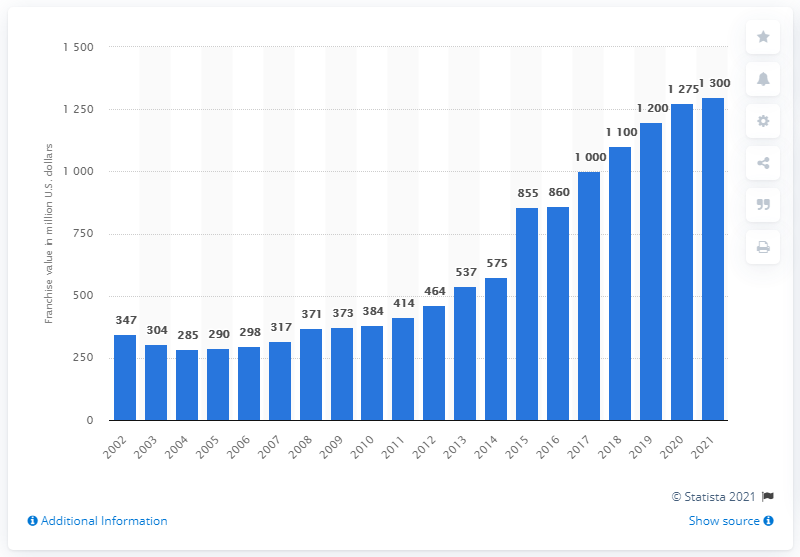Give some essential details in this illustration. In 2021, the estimated value of the Colorado Rockies was approximately $1,300 million. 